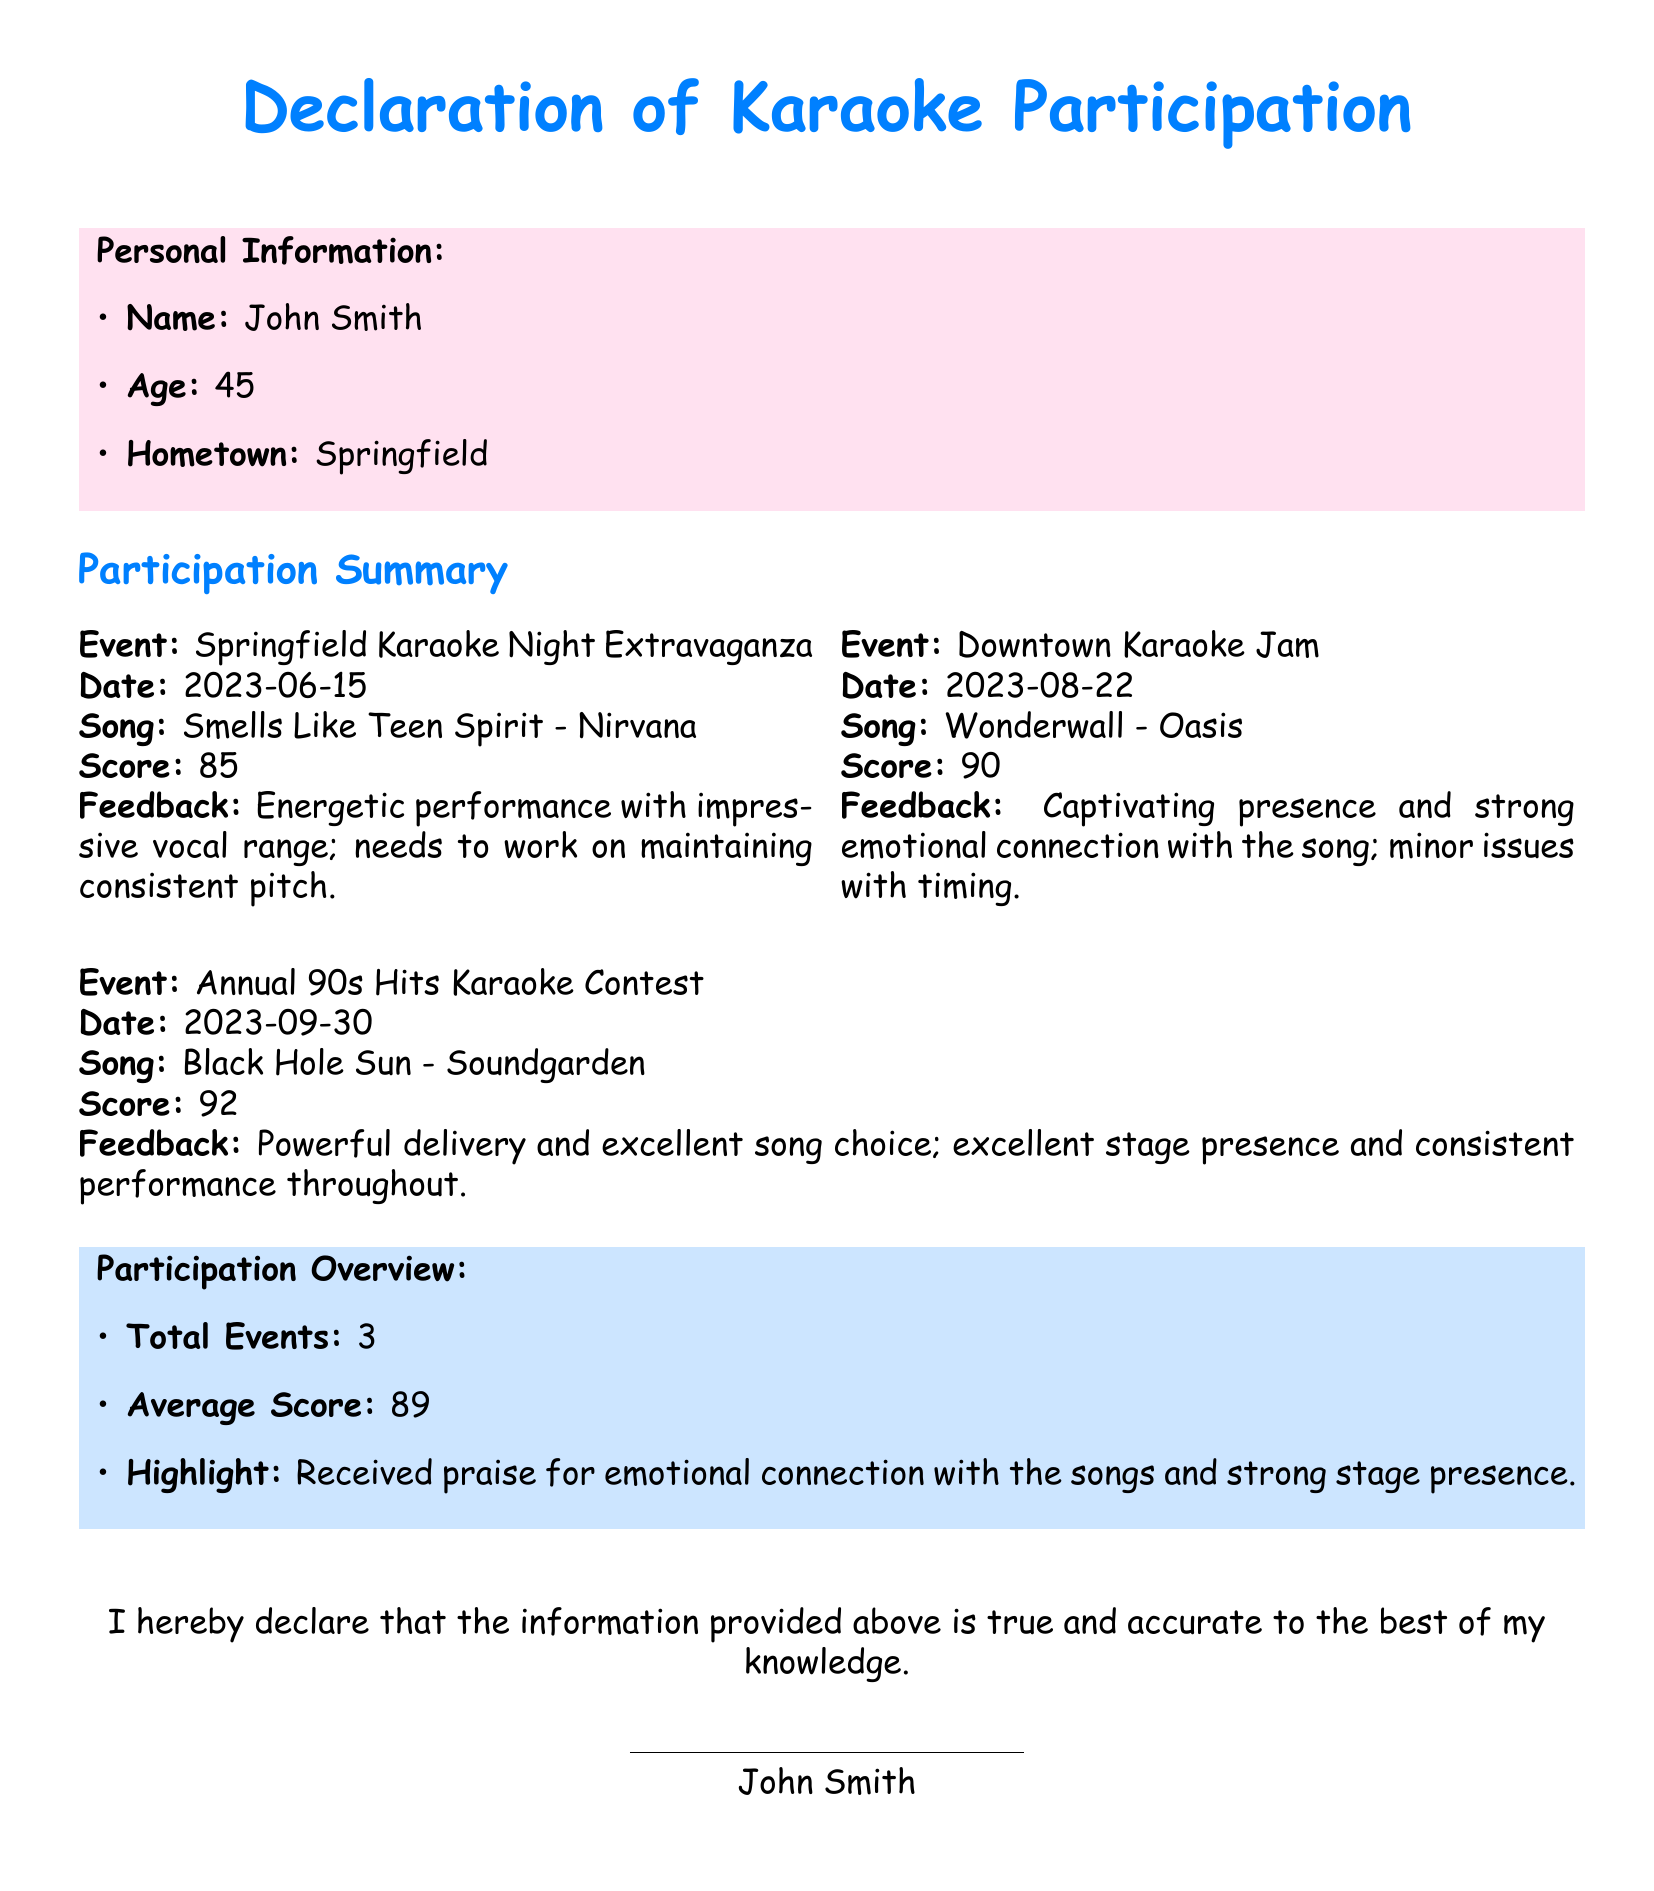What is the name of the participant? The document specifies the participant's name at the top under Personal Information.
Answer: John Smith What is the total number of events participated in? The total number of events is listed in the Participation Overview section.
Answer: 3 What was the score for "Wonderwall"? The score for "Wonderwall" can be found under the corresponding event details.
Answer: 90 What date did the Annual 90s Hits Karaoke Contest take place? The date is provided right next to the event name in its respective section.
Answer: 2023-09-30 What feedback was given for the performance of "Smells Like Teen Spirit"? Feedback is included in the details related to each performed song.
Answer: Energetic performance with impressive vocal range; needs to work on maintaining consistent pitch What was the average score across all events? The average score is indicated in the Participation Overview.
Answer: 89 Which song received the highest score? The highest score is listed next to its respective song in the document.
Answer: Black Hole Sun What was praised in the overall feedback summary? The Participation Overview provides a summary of feedback received across performances.
Answer: Emotional connection with the songs and strong stage presence When did the Downtown Karaoke Jam occur? The date for this event is indicated in the section detailing the event.
Answer: 2023-08-22 